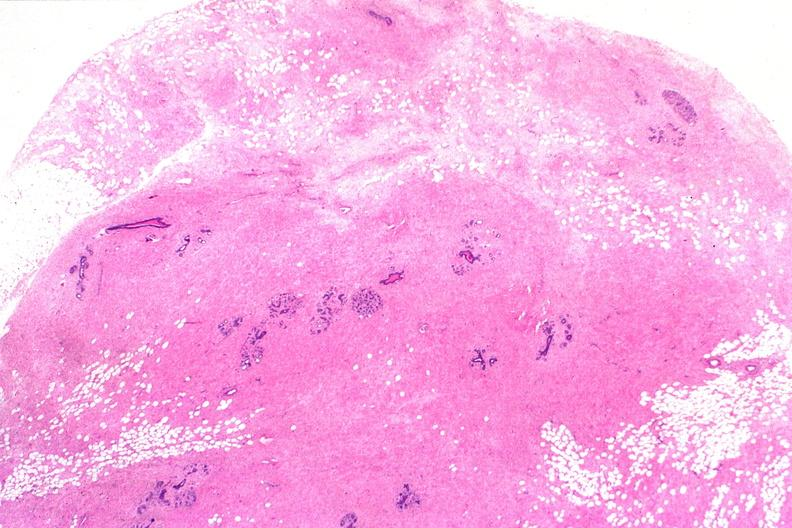does this image show normal breast?
Answer the question using a single word or phrase. Yes 